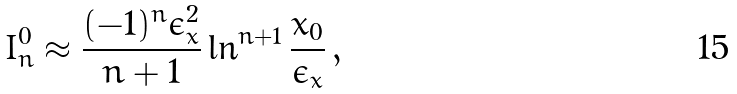<formula> <loc_0><loc_0><loc_500><loc_500>I ^ { 0 } _ { n } \approx \frac { ( - 1 ) ^ { n } \epsilon _ { x } ^ { 2 } } { n + 1 } \ln ^ { n + 1 } \frac { x _ { 0 } } { \epsilon _ { x } } \, ,</formula> 